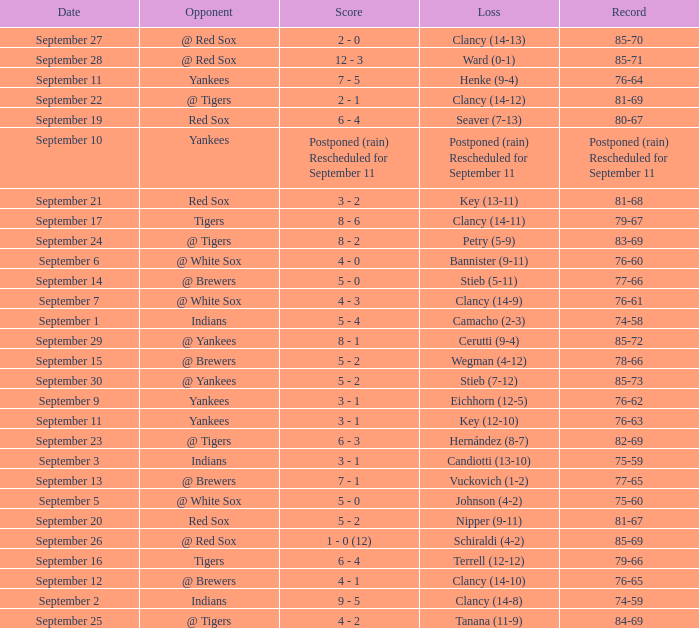Who was the Blue Jays opponent when their record was 84-69? @ Tigers. 